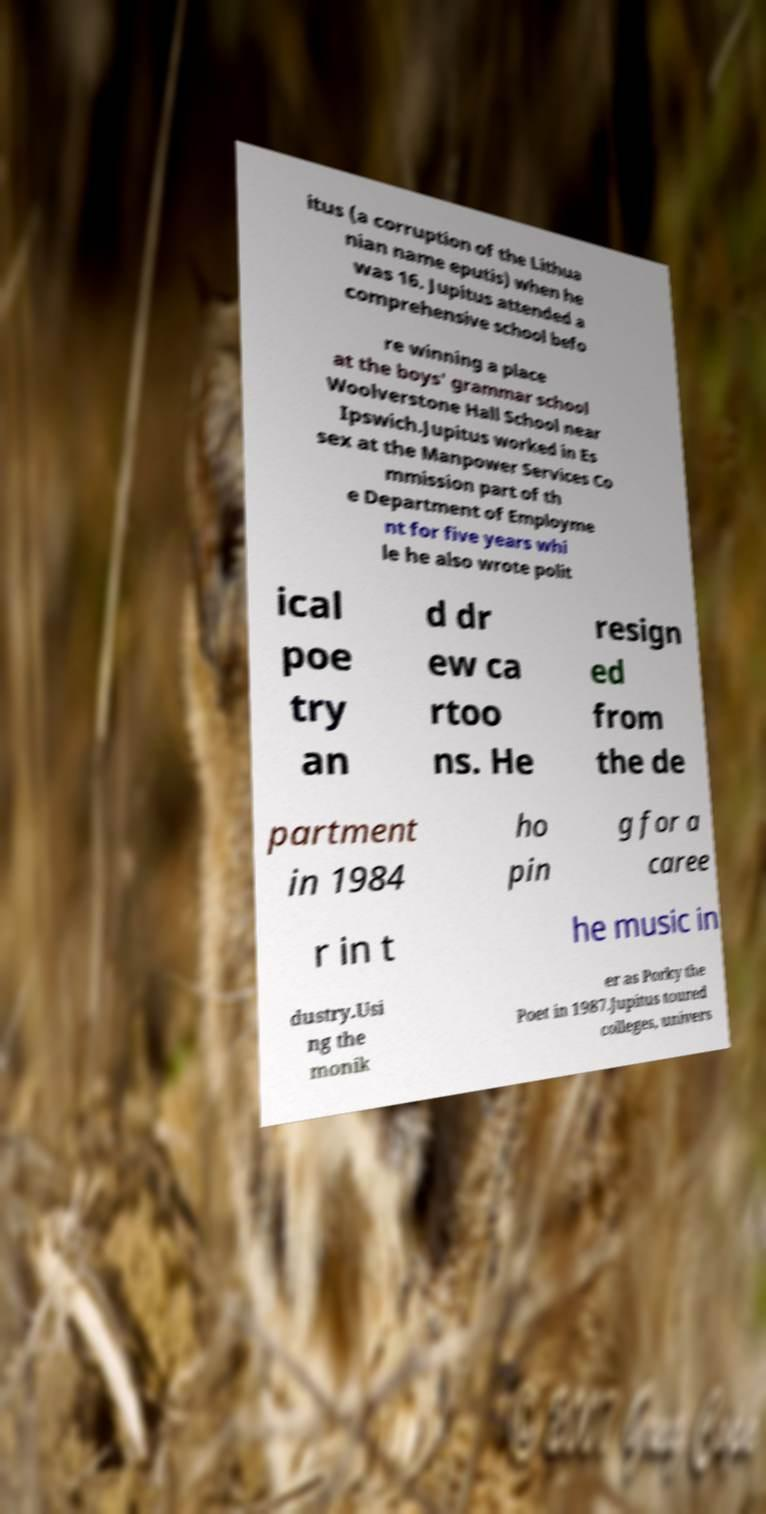What messages or text are displayed in this image? I need them in a readable, typed format. itus (a corruption of the Lithua nian name eputis) when he was 16. Jupitus attended a comprehensive school befo re winning a place at the boys' grammar school Woolverstone Hall School near Ipswich.Jupitus worked in Es sex at the Manpower Services Co mmission part of th e Department of Employme nt for five years whi le he also wrote polit ical poe try an d dr ew ca rtoo ns. He resign ed from the de partment in 1984 ho pin g for a caree r in t he music in dustry.Usi ng the monik er as Porky the Poet in 1987.Jupitus toured colleges, univers 